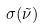Convert formula to latex. <formula><loc_0><loc_0><loc_500><loc_500>\sigma ( \tilde { \nu } )</formula> 